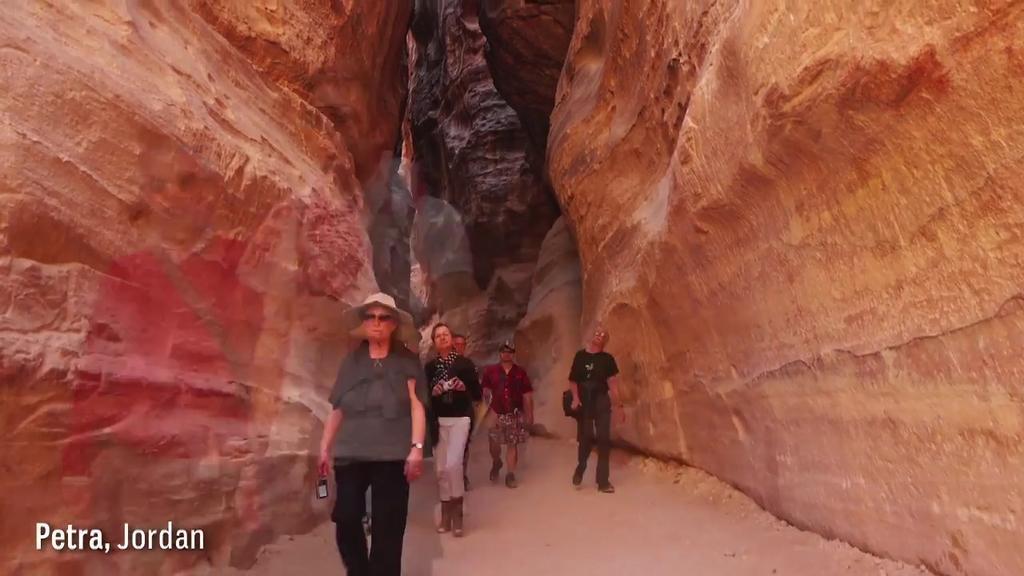Describe this image in one or two sentences. In the image there are few persons walking on the path, on either side of it there are red sand stone hills. 